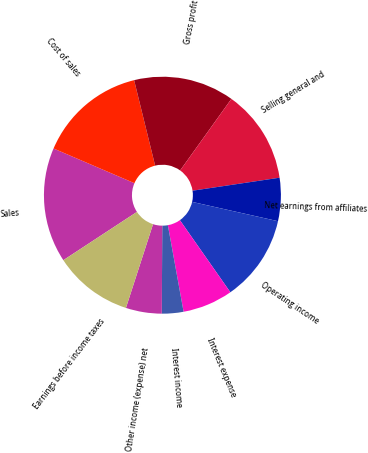Convert chart. <chart><loc_0><loc_0><loc_500><loc_500><pie_chart><fcel>Sales<fcel>Cost of sales<fcel>Gross profit<fcel>Selling general and<fcel>Net earnings from affiliates<fcel>Operating income<fcel>Interest expense<fcel>Interest income<fcel>Other income (expense) net<fcel>Earnings before income taxes<nl><fcel>15.69%<fcel>14.71%<fcel>13.73%<fcel>12.75%<fcel>5.88%<fcel>11.76%<fcel>6.86%<fcel>2.94%<fcel>4.9%<fcel>10.78%<nl></chart> 